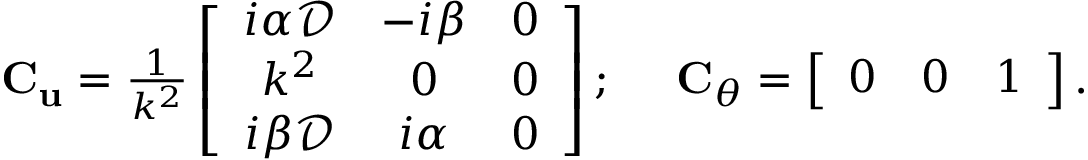<formula> <loc_0><loc_0><loc_500><loc_500>\begin{array} { r } { C _ { u } = \frac { 1 } { k ^ { 2 } } \left [ \begin{array} { c c c } { i \alpha \mathcal { D } } & { - i \beta } & { 0 } \\ { k ^ { 2 } } & { 0 } & { 0 } \\ { i \beta \mathcal { D } } & { i \alpha } & { 0 } \end{array} \right ] ; C _ { \theta } = \left [ \begin{array} { c c c } { 0 } & { 0 } & { 1 } \end{array} \right ] . } \end{array}</formula> 